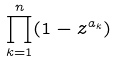Convert formula to latex. <formula><loc_0><loc_0><loc_500><loc_500>\prod _ { k = 1 } ^ { n } ( 1 - z ^ { a _ { k } } )</formula> 